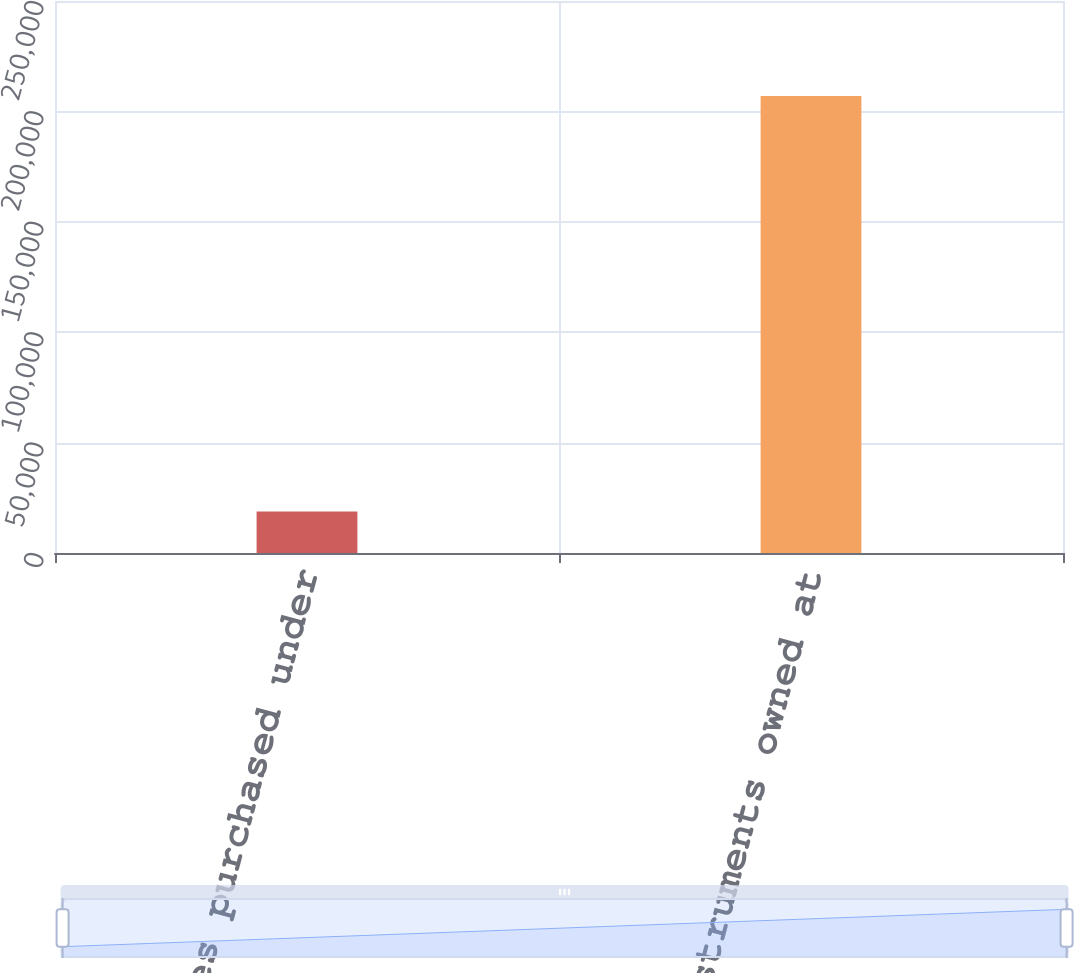Convert chart to OTSL. <chart><loc_0><loc_0><loc_500><loc_500><bar_chart><fcel>Securities purchased under<fcel>Financial instruments owned at<nl><fcel>18844<fcel>206988<nl></chart> 